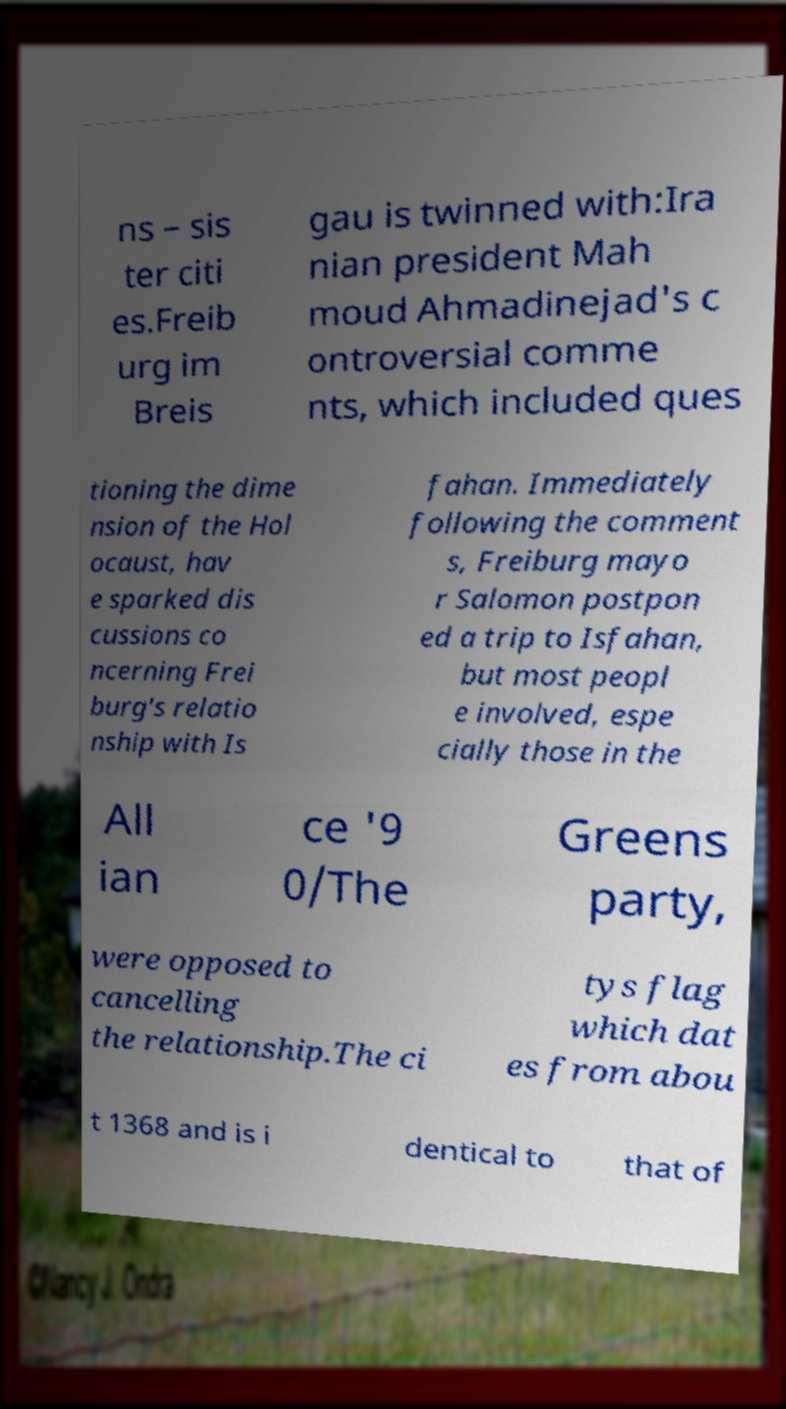I need the written content from this picture converted into text. Can you do that? ns – sis ter citi es.Freib urg im Breis gau is twinned with:Ira nian president Mah moud Ahmadinejad's c ontroversial comme nts, which included ques tioning the dime nsion of the Hol ocaust, hav e sparked dis cussions co ncerning Frei burg's relatio nship with Is fahan. Immediately following the comment s, Freiburg mayo r Salomon postpon ed a trip to Isfahan, but most peopl e involved, espe cially those in the All ian ce '9 0/The Greens party, were opposed to cancelling the relationship.The ci tys flag which dat es from abou t 1368 and is i dentical to that of 